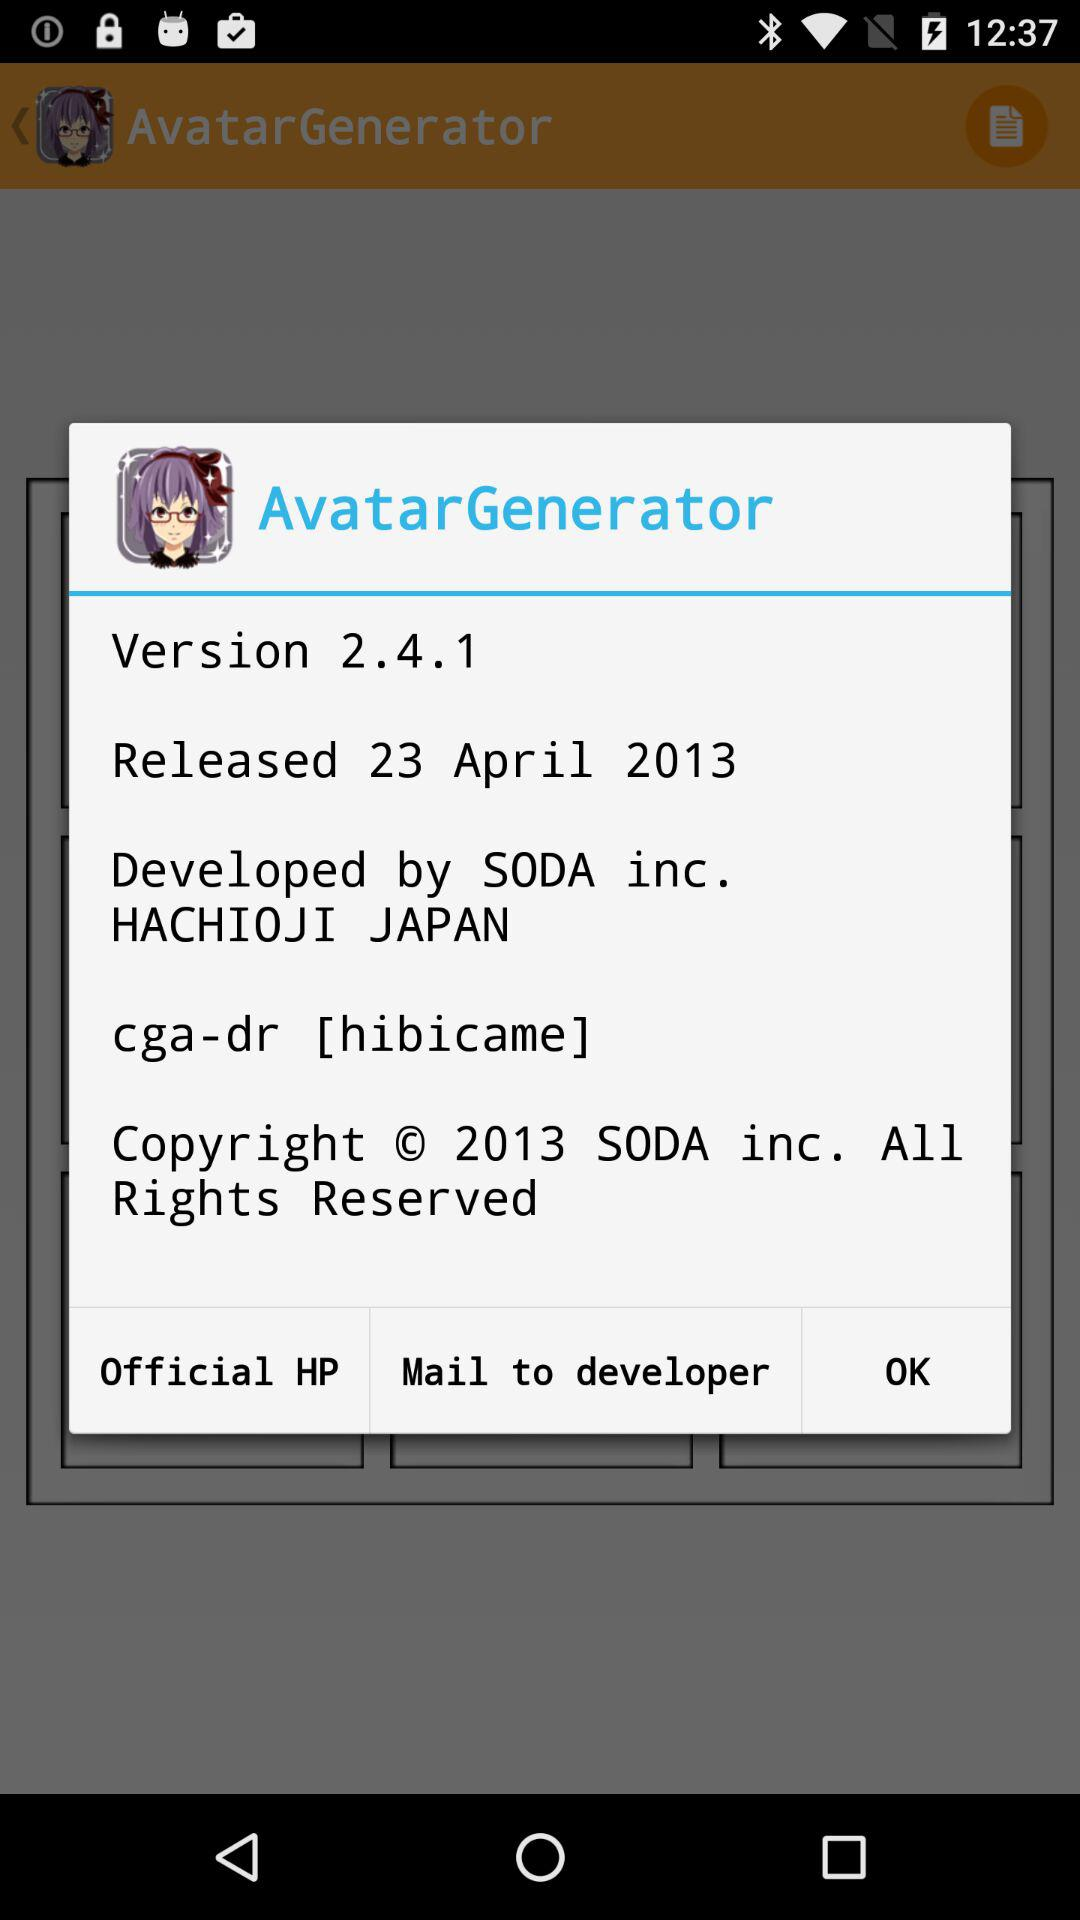Who developed the application? The application was developed by "SODA inc.". 